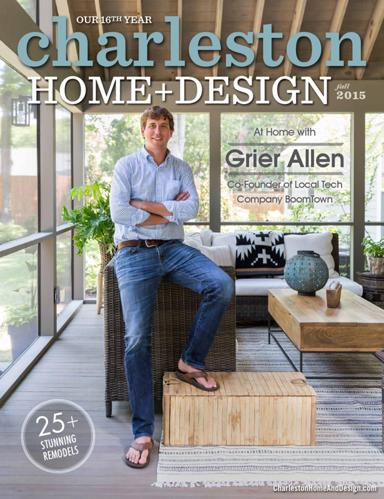What details on the cover suggest this magazine issue focuses on home remodels? The cover hints at a focus on home remodels through the text '25+ stunning remodels' prominently displayed. Additionally, the featured interior showcases a beautifully renovated space, indicating the content's emphasis on transformation and design innovation. 